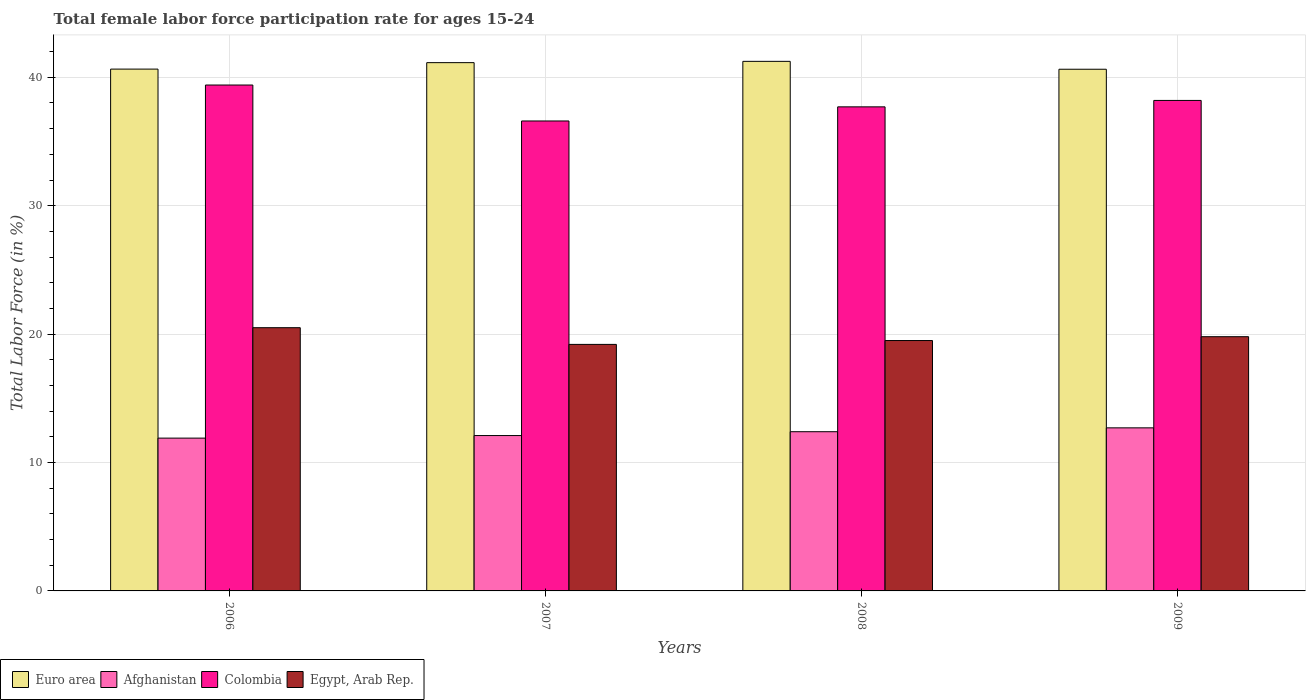How many bars are there on the 3rd tick from the right?
Provide a short and direct response. 4. What is the female labor force participation rate in Afghanistan in 2009?
Make the answer very short. 12.7. Across all years, what is the maximum female labor force participation rate in Colombia?
Offer a very short reply. 39.4. Across all years, what is the minimum female labor force participation rate in Colombia?
Keep it short and to the point. 36.6. In which year was the female labor force participation rate in Euro area minimum?
Keep it short and to the point. 2009. What is the total female labor force participation rate in Egypt, Arab Rep. in the graph?
Offer a terse response. 79. What is the difference between the female labor force participation rate in Egypt, Arab Rep. in 2007 and that in 2008?
Keep it short and to the point. -0.3. What is the difference between the female labor force participation rate in Colombia in 2007 and the female labor force participation rate in Egypt, Arab Rep. in 2009?
Offer a very short reply. 16.8. What is the average female labor force participation rate in Euro area per year?
Keep it short and to the point. 40.91. In the year 2007, what is the difference between the female labor force participation rate in Afghanistan and female labor force participation rate in Euro area?
Your answer should be very brief. -29.04. What is the ratio of the female labor force participation rate in Egypt, Arab Rep. in 2006 to that in 2008?
Offer a terse response. 1.05. Is the female labor force participation rate in Egypt, Arab Rep. in 2006 less than that in 2009?
Ensure brevity in your answer.  No. What is the difference between the highest and the second highest female labor force participation rate in Egypt, Arab Rep.?
Your response must be concise. 0.7. What is the difference between the highest and the lowest female labor force participation rate in Afghanistan?
Give a very brief answer. 0.8. Is it the case that in every year, the sum of the female labor force participation rate in Euro area and female labor force participation rate in Colombia is greater than the sum of female labor force participation rate in Afghanistan and female labor force participation rate in Egypt, Arab Rep.?
Offer a very short reply. No. What does the 3rd bar from the left in 2007 represents?
Keep it short and to the point. Colombia. What does the 4th bar from the right in 2006 represents?
Offer a very short reply. Euro area. Is it the case that in every year, the sum of the female labor force participation rate in Egypt, Arab Rep. and female labor force participation rate in Euro area is greater than the female labor force participation rate in Afghanistan?
Provide a succinct answer. Yes. How many years are there in the graph?
Offer a terse response. 4. What is the difference between two consecutive major ticks on the Y-axis?
Make the answer very short. 10. Does the graph contain grids?
Offer a terse response. Yes. How many legend labels are there?
Offer a very short reply. 4. How are the legend labels stacked?
Your answer should be very brief. Horizontal. What is the title of the graph?
Make the answer very short. Total female labor force participation rate for ages 15-24. Does "Madagascar" appear as one of the legend labels in the graph?
Provide a succinct answer. No. What is the Total Labor Force (in %) of Euro area in 2006?
Keep it short and to the point. 40.64. What is the Total Labor Force (in %) of Afghanistan in 2006?
Your response must be concise. 11.9. What is the Total Labor Force (in %) of Colombia in 2006?
Offer a terse response. 39.4. What is the Total Labor Force (in %) of Euro area in 2007?
Offer a very short reply. 41.14. What is the Total Labor Force (in %) in Afghanistan in 2007?
Offer a very short reply. 12.1. What is the Total Labor Force (in %) of Colombia in 2007?
Your answer should be compact. 36.6. What is the Total Labor Force (in %) in Egypt, Arab Rep. in 2007?
Provide a succinct answer. 19.2. What is the Total Labor Force (in %) in Euro area in 2008?
Your answer should be compact. 41.24. What is the Total Labor Force (in %) of Afghanistan in 2008?
Your answer should be very brief. 12.4. What is the Total Labor Force (in %) of Colombia in 2008?
Provide a short and direct response. 37.7. What is the Total Labor Force (in %) in Egypt, Arab Rep. in 2008?
Provide a short and direct response. 19.5. What is the Total Labor Force (in %) of Euro area in 2009?
Provide a short and direct response. 40.63. What is the Total Labor Force (in %) in Afghanistan in 2009?
Provide a succinct answer. 12.7. What is the Total Labor Force (in %) in Colombia in 2009?
Keep it short and to the point. 38.2. What is the Total Labor Force (in %) of Egypt, Arab Rep. in 2009?
Ensure brevity in your answer.  19.8. Across all years, what is the maximum Total Labor Force (in %) of Euro area?
Offer a terse response. 41.24. Across all years, what is the maximum Total Labor Force (in %) in Afghanistan?
Your answer should be very brief. 12.7. Across all years, what is the maximum Total Labor Force (in %) in Colombia?
Your answer should be very brief. 39.4. Across all years, what is the maximum Total Labor Force (in %) in Egypt, Arab Rep.?
Ensure brevity in your answer.  20.5. Across all years, what is the minimum Total Labor Force (in %) in Euro area?
Make the answer very short. 40.63. Across all years, what is the minimum Total Labor Force (in %) in Afghanistan?
Your answer should be compact. 11.9. Across all years, what is the minimum Total Labor Force (in %) in Colombia?
Ensure brevity in your answer.  36.6. Across all years, what is the minimum Total Labor Force (in %) of Egypt, Arab Rep.?
Provide a succinct answer. 19.2. What is the total Total Labor Force (in %) in Euro area in the graph?
Give a very brief answer. 163.65. What is the total Total Labor Force (in %) in Afghanistan in the graph?
Provide a short and direct response. 49.1. What is the total Total Labor Force (in %) of Colombia in the graph?
Give a very brief answer. 151.9. What is the total Total Labor Force (in %) in Egypt, Arab Rep. in the graph?
Your answer should be compact. 79. What is the difference between the Total Labor Force (in %) in Euro area in 2006 and that in 2007?
Provide a short and direct response. -0.5. What is the difference between the Total Labor Force (in %) in Afghanistan in 2006 and that in 2007?
Give a very brief answer. -0.2. What is the difference between the Total Labor Force (in %) of Euro area in 2006 and that in 2008?
Offer a very short reply. -0.6. What is the difference between the Total Labor Force (in %) of Euro area in 2006 and that in 2009?
Keep it short and to the point. 0.01. What is the difference between the Total Labor Force (in %) in Afghanistan in 2006 and that in 2009?
Your response must be concise. -0.8. What is the difference between the Total Labor Force (in %) of Egypt, Arab Rep. in 2006 and that in 2009?
Provide a short and direct response. 0.7. What is the difference between the Total Labor Force (in %) in Euro area in 2007 and that in 2008?
Ensure brevity in your answer.  -0.1. What is the difference between the Total Labor Force (in %) in Colombia in 2007 and that in 2008?
Your answer should be compact. -1.1. What is the difference between the Total Labor Force (in %) of Euro area in 2007 and that in 2009?
Provide a short and direct response. 0.51. What is the difference between the Total Labor Force (in %) in Afghanistan in 2007 and that in 2009?
Keep it short and to the point. -0.6. What is the difference between the Total Labor Force (in %) in Egypt, Arab Rep. in 2007 and that in 2009?
Make the answer very short. -0.6. What is the difference between the Total Labor Force (in %) in Euro area in 2008 and that in 2009?
Your response must be concise. 0.61. What is the difference between the Total Labor Force (in %) of Afghanistan in 2008 and that in 2009?
Ensure brevity in your answer.  -0.3. What is the difference between the Total Labor Force (in %) of Euro area in 2006 and the Total Labor Force (in %) of Afghanistan in 2007?
Provide a short and direct response. 28.54. What is the difference between the Total Labor Force (in %) of Euro area in 2006 and the Total Labor Force (in %) of Colombia in 2007?
Ensure brevity in your answer.  4.04. What is the difference between the Total Labor Force (in %) in Euro area in 2006 and the Total Labor Force (in %) in Egypt, Arab Rep. in 2007?
Keep it short and to the point. 21.44. What is the difference between the Total Labor Force (in %) of Afghanistan in 2006 and the Total Labor Force (in %) of Colombia in 2007?
Offer a very short reply. -24.7. What is the difference between the Total Labor Force (in %) of Colombia in 2006 and the Total Labor Force (in %) of Egypt, Arab Rep. in 2007?
Give a very brief answer. 20.2. What is the difference between the Total Labor Force (in %) of Euro area in 2006 and the Total Labor Force (in %) of Afghanistan in 2008?
Provide a short and direct response. 28.24. What is the difference between the Total Labor Force (in %) in Euro area in 2006 and the Total Labor Force (in %) in Colombia in 2008?
Ensure brevity in your answer.  2.94. What is the difference between the Total Labor Force (in %) of Euro area in 2006 and the Total Labor Force (in %) of Egypt, Arab Rep. in 2008?
Give a very brief answer. 21.14. What is the difference between the Total Labor Force (in %) of Afghanistan in 2006 and the Total Labor Force (in %) of Colombia in 2008?
Provide a short and direct response. -25.8. What is the difference between the Total Labor Force (in %) of Colombia in 2006 and the Total Labor Force (in %) of Egypt, Arab Rep. in 2008?
Your answer should be compact. 19.9. What is the difference between the Total Labor Force (in %) in Euro area in 2006 and the Total Labor Force (in %) in Afghanistan in 2009?
Offer a terse response. 27.94. What is the difference between the Total Labor Force (in %) in Euro area in 2006 and the Total Labor Force (in %) in Colombia in 2009?
Offer a very short reply. 2.44. What is the difference between the Total Labor Force (in %) in Euro area in 2006 and the Total Labor Force (in %) in Egypt, Arab Rep. in 2009?
Give a very brief answer. 20.84. What is the difference between the Total Labor Force (in %) of Afghanistan in 2006 and the Total Labor Force (in %) of Colombia in 2009?
Give a very brief answer. -26.3. What is the difference between the Total Labor Force (in %) in Colombia in 2006 and the Total Labor Force (in %) in Egypt, Arab Rep. in 2009?
Provide a succinct answer. 19.6. What is the difference between the Total Labor Force (in %) of Euro area in 2007 and the Total Labor Force (in %) of Afghanistan in 2008?
Your answer should be very brief. 28.74. What is the difference between the Total Labor Force (in %) of Euro area in 2007 and the Total Labor Force (in %) of Colombia in 2008?
Keep it short and to the point. 3.44. What is the difference between the Total Labor Force (in %) in Euro area in 2007 and the Total Labor Force (in %) in Egypt, Arab Rep. in 2008?
Your answer should be very brief. 21.64. What is the difference between the Total Labor Force (in %) in Afghanistan in 2007 and the Total Labor Force (in %) in Colombia in 2008?
Your answer should be compact. -25.6. What is the difference between the Total Labor Force (in %) in Colombia in 2007 and the Total Labor Force (in %) in Egypt, Arab Rep. in 2008?
Your response must be concise. 17.1. What is the difference between the Total Labor Force (in %) in Euro area in 2007 and the Total Labor Force (in %) in Afghanistan in 2009?
Your answer should be compact. 28.44. What is the difference between the Total Labor Force (in %) in Euro area in 2007 and the Total Labor Force (in %) in Colombia in 2009?
Your answer should be compact. 2.94. What is the difference between the Total Labor Force (in %) in Euro area in 2007 and the Total Labor Force (in %) in Egypt, Arab Rep. in 2009?
Offer a terse response. 21.34. What is the difference between the Total Labor Force (in %) of Afghanistan in 2007 and the Total Labor Force (in %) of Colombia in 2009?
Give a very brief answer. -26.1. What is the difference between the Total Labor Force (in %) of Afghanistan in 2007 and the Total Labor Force (in %) of Egypt, Arab Rep. in 2009?
Offer a terse response. -7.7. What is the difference between the Total Labor Force (in %) in Euro area in 2008 and the Total Labor Force (in %) in Afghanistan in 2009?
Keep it short and to the point. 28.54. What is the difference between the Total Labor Force (in %) in Euro area in 2008 and the Total Labor Force (in %) in Colombia in 2009?
Make the answer very short. 3.04. What is the difference between the Total Labor Force (in %) in Euro area in 2008 and the Total Labor Force (in %) in Egypt, Arab Rep. in 2009?
Ensure brevity in your answer.  21.44. What is the difference between the Total Labor Force (in %) in Afghanistan in 2008 and the Total Labor Force (in %) in Colombia in 2009?
Keep it short and to the point. -25.8. What is the average Total Labor Force (in %) in Euro area per year?
Your answer should be compact. 40.91. What is the average Total Labor Force (in %) in Afghanistan per year?
Ensure brevity in your answer.  12.28. What is the average Total Labor Force (in %) of Colombia per year?
Your response must be concise. 37.98. What is the average Total Labor Force (in %) of Egypt, Arab Rep. per year?
Offer a very short reply. 19.75. In the year 2006, what is the difference between the Total Labor Force (in %) in Euro area and Total Labor Force (in %) in Afghanistan?
Your answer should be very brief. 28.74. In the year 2006, what is the difference between the Total Labor Force (in %) of Euro area and Total Labor Force (in %) of Colombia?
Your answer should be very brief. 1.24. In the year 2006, what is the difference between the Total Labor Force (in %) of Euro area and Total Labor Force (in %) of Egypt, Arab Rep.?
Make the answer very short. 20.14. In the year 2006, what is the difference between the Total Labor Force (in %) of Afghanistan and Total Labor Force (in %) of Colombia?
Offer a very short reply. -27.5. In the year 2006, what is the difference between the Total Labor Force (in %) of Colombia and Total Labor Force (in %) of Egypt, Arab Rep.?
Provide a succinct answer. 18.9. In the year 2007, what is the difference between the Total Labor Force (in %) of Euro area and Total Labor Force (in %) of Afghanistan?
Make the answer very short. 29.04. In the year 2007, what is the difference between the Total Labor Force (in %) of Euro area and Total Labor Force (in %) of Colombia?
Your answer should be very brief. 4.54. In the year 2007, what is the difference between the Total Labor Force (in %) of Euro area and Total Labor Force (in %) of Egypt, Arab Rep.?
Make the answer very short. 21.94. In the year 2007, what is the difference between the Total Labor Force (in %) in Afghanistan and Total Labor Force (in %) in Colombia?
Provide a short and direct response. -24.5. In the year 2008, what is the difference between the Total Labor Force (in %) of Euro area and Total Labor Force (in %) of Afghanistan?
Provide a short and direct response. 28.84. In the year 2008, what is the difference between the Total Labor Force (in %) in Euro area and Total Labor Force (in %) in Colombia?
Give a very brief answer. 3.54. In the year 2008, what is the difference between the Total Labor Force (in %) in Euro area and Total Labor Force (in %) in Egypt, Arab Rep.?
Offer a terse response. 21.74. In the year 2008, what is the difference between the Total Labor Force (in %) of Afghanistan and Total Labor Force (in %) of Colombia?
Offer a very short reply. -25.3. In the year 2009, what is the difference between the Total Labor Force (in %) in Euro area and Total Labor Force (in %) in Afghanistan?
Provide a short and direct response. 27.93. In the year 2009, what is the difference between the Total Labor Force (in %) in Euro area and Total Labor Force (in %) in Colombia?
Give a very brief answer. 2.43. In the year 2009, what is the difference between the Total Labor Force (in %) in Euro area and Total Labor Force (in %) in Egypt, Arab Rep.?
Your answer should be very brief. 20.83. In the year 2009, what is the difference between the Total Labor Force (in %) of Afghanistan and Total Labor Force (in %) of Colombia?
Keep it short and to the point. -25.5. In the year 2009, what is the difference between the Total Labor Force (in %) in Afghanistan and Total Labor Force (in %) in Egypt, Arab Rep.?
Your answer should be very brief. -7.1. In the year 2009, what is the difference between the Total Labor Force (in %) of Colombia and Total Labor Force (in %) of Egypt, Arab Rep.?
Offer a terse response. 18.4. What is the ratio of the Total Labor Force (in %) of Euro area in 2006 to that in 2007?
Offer a very short reply. 0.99. What is the ratio of the Total Labor Force (in %) of Afghanistan in 2006 to that in 2007?
Your answer should be compact. 0.98. What is the ratio of the Total Labor Force (in %) of Colombia in 2006 to that in 2007?
Offer a terse response. 1.08. What is the ratio of the Total Labor Force (in %) of Egypt, Arab Rep. in 2006 to that in 2007?
Your response must be concise. 1.07. What is the ratio of the Total Labor Force (in %) of Euro area in 2006 to that in 2008?
Make the answer very short. 0.99. What is the ratio of the Total Labor Force (in %) of Afghanistan in 2006 to that in 2008?
Provide a short and direct response. 0.96. What is the ratio of the Total Labor Force (in %) in Colombia in 2006 to that in 2008?
Make the answer very short. 1.05. What is the ratio of the Total Labor Force (in %) of Egypt, Arab Rep. in 2006 to that in 2008?
Your response must be concise. 1.05. What is the ratio of the Total Labor Force (in %) of Afghanistan in 2006 to that in 2009?
Provide a succinct answer. 0.94. What is the ratio of the Total Labor Force (in %) of Colombia in 2006 to that in 2009?
Ensure brevity in your answer.  1.03. What is the ratio of the Total Labor Force (in %) in Egypt, Arab Rep. in 2006 to that in 2009?
Ensure brevity in your answer.  1.04. What is the ratio of the Total Labor Force (in %) of Afghanistan in 2007 to that in 2008?
Ensure brevity in your answer.  0.98. What is the ratio of the Total Labor Force (in %) in Colombia in 2007 to that in 2008?
Offer a terse response. 0.97. What is the ratio of the Total Labor Force (in %) in Egypt, Arab Rep. in 2007 to that in 2008?
Give a very brief answer. 0.98. What is the ratio of the Total Labor Force (in %) of Euro area in 2007 to that in 2009?
Provide a succinct answer. 1.01. What is the ratio of the Total Labor Force (in %) of Afghanistan in 2007 to that in 2009?
Make the answer very short. 0.95. What is the ratio of the Total Labor Force (in %) of Colombia in 2007 to that in 2009?
Your answer should be very brief. 0.96. What is the ratio of the Total Labor Force (in %) of Egypt, Arab Rep. in 2007 to that in 2009?
Offer a terse response. 0.97. What is the ratio of the Total Labor Force (in %) in Euro area in 2008 to that in 2009?
Provide a succinct answer. 1.02. What is the ratio of the Total Labor Force (in %) in Afghanistan in 2008 to that in 2009?
Offer a terse response. 0.98. What is the ratio of the Total Labor Force (in %) in Colombia in 2008 to that in 2009?
Offer a terse response. 0.99. What is the difference between the highest and the second highest Total Labor Force (in %) in Euro area?
Ensure brevity in your answer.  0.1. What is the difference between the highest and the second highest Total Labor Force (in %) of Afghanistan?
Provide a succinct answer. 0.3. What is the difference between the highest and the second highest Total Labor Force (in %) in Egypt, Arab Rep.?
Your response must be concise. 0.7. What is the difference between the highest and the lowest Total Labor Force (in %) in Euro area?
Provide a short and direct response. 0.61. What is the difference between the highest and the lowest Total Labor Force (in %) of Afghanistan?
Give a very brief answer. 0.8. 